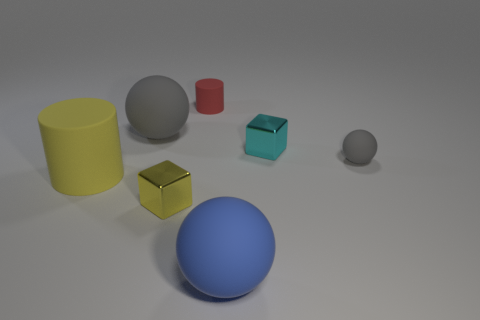Can you speculate on the purpose of this arrangement? This arrangement appears to be a deliberately composed collection of geometric shapes, possibly for the purpose of visual or aesthetic demonstration. It could be used to illustrate concepts in geometry, shading, lighting, and material properties in a three-dimensional rendering or an educational setting. 